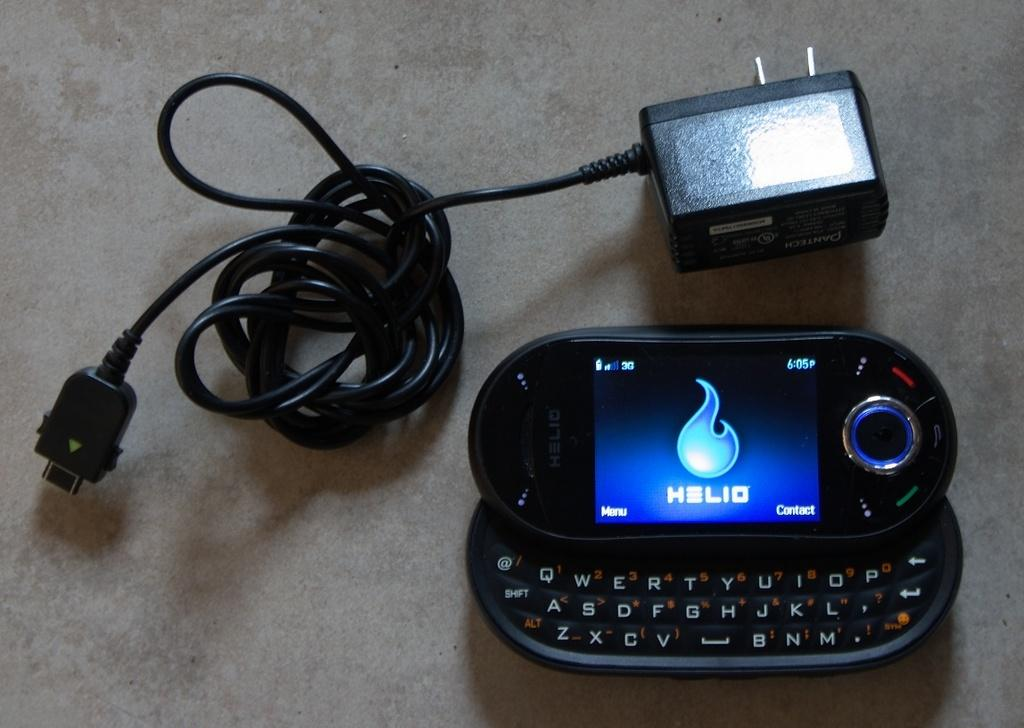<image>
Summarize the visual content of the image. A phone sits with the charger and is made by the compay Helio. 